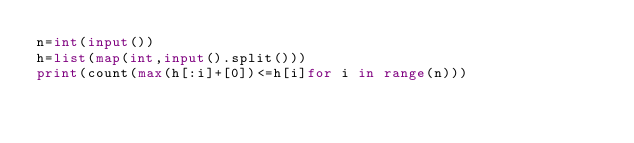<code> <loc_0><loc_0><loc_500><loc_500><_Python_>n=int(input())
h=list(map(int,input().split()))
print(count(max(h[:i]+[0])<=h[i]for i in range(n)))</code> 